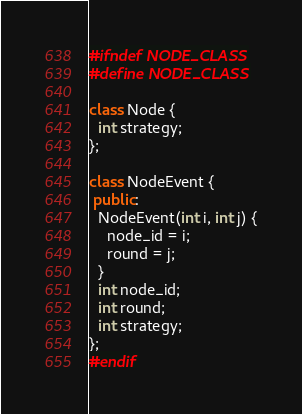<code> <loc_0><loc_0><loc_500><loc_500><_C++_>#ifndef NODE_CLASS
#define NODE_CLASS

class Node {
  int strategy;
};

class NodeEvent {
 public:
  NodeEvent(int i, int j) {
    node_id = i;
    round = j;
  }
  int node_id;
  int round;
  int strategy;
};
#endif</code> 